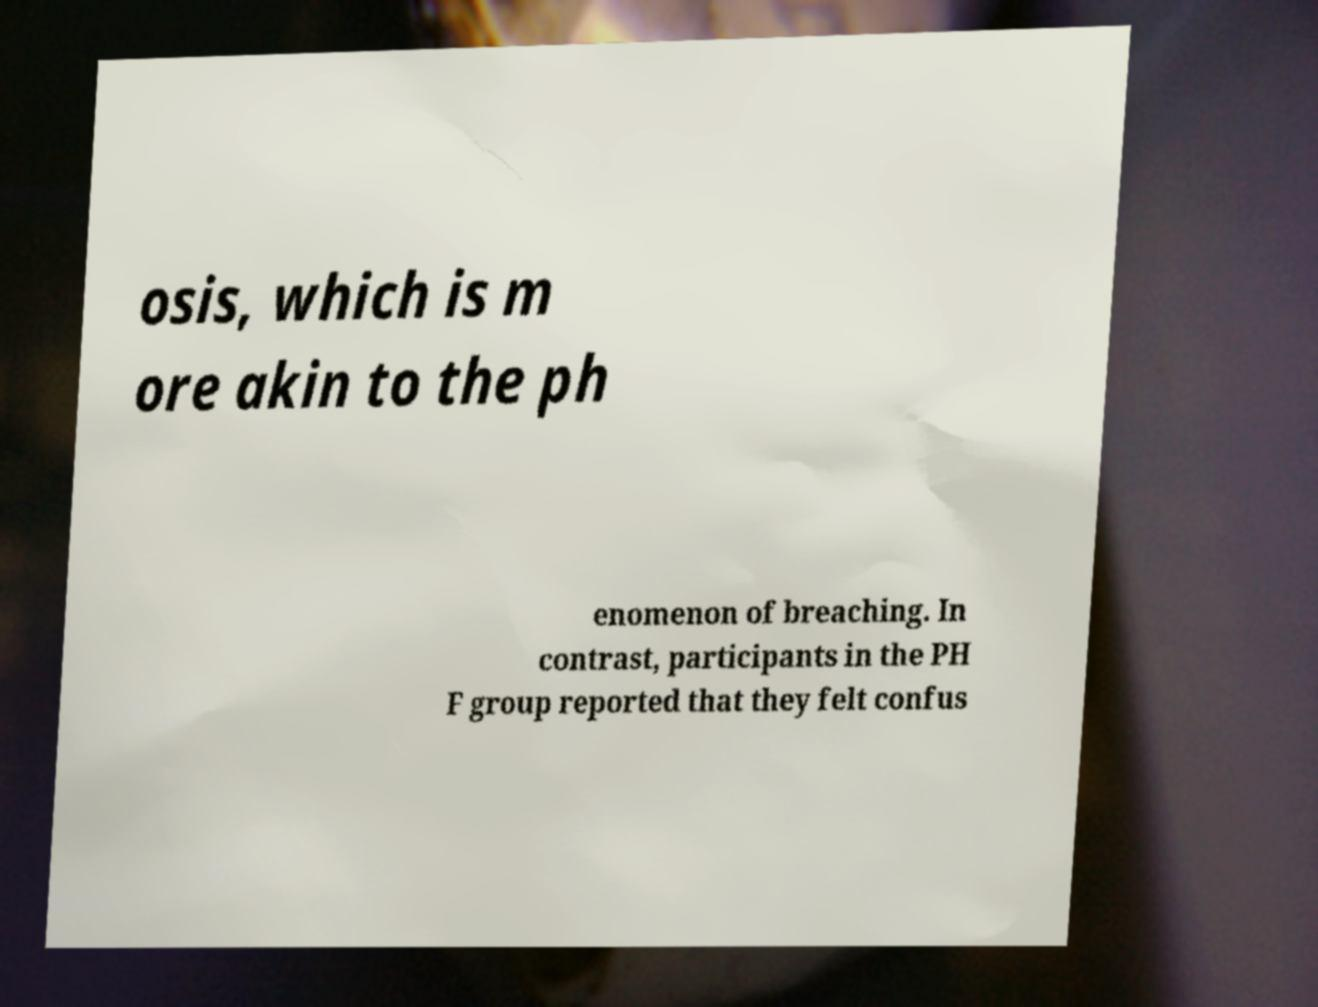What messages or text are displayed in this image? I need them in a readable, typed format. osis, which is m ore akin to the ph enomenon of breaching. In contrast, participants in the PH F group reported that they felt confus 